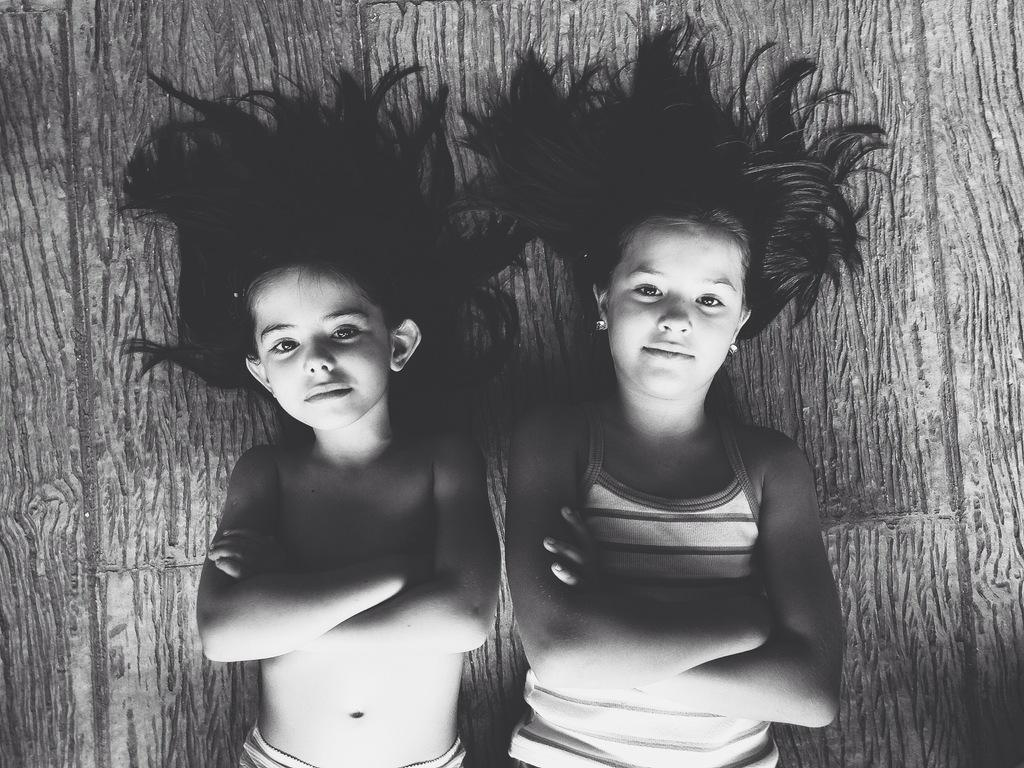How many kids are present in the image? There are two kids in the image. What are the kids doing in the image? The kids are lying down. What is the color scheme of the image? The image is a black and white photography. What type of nail is the kid holding in the image? There is no nail present in the image; the kids are lying down in a black and white photography. What type of work are the kids doing as slaves in the image? There is no indication in the image that the kids are slaves or performing any work. 